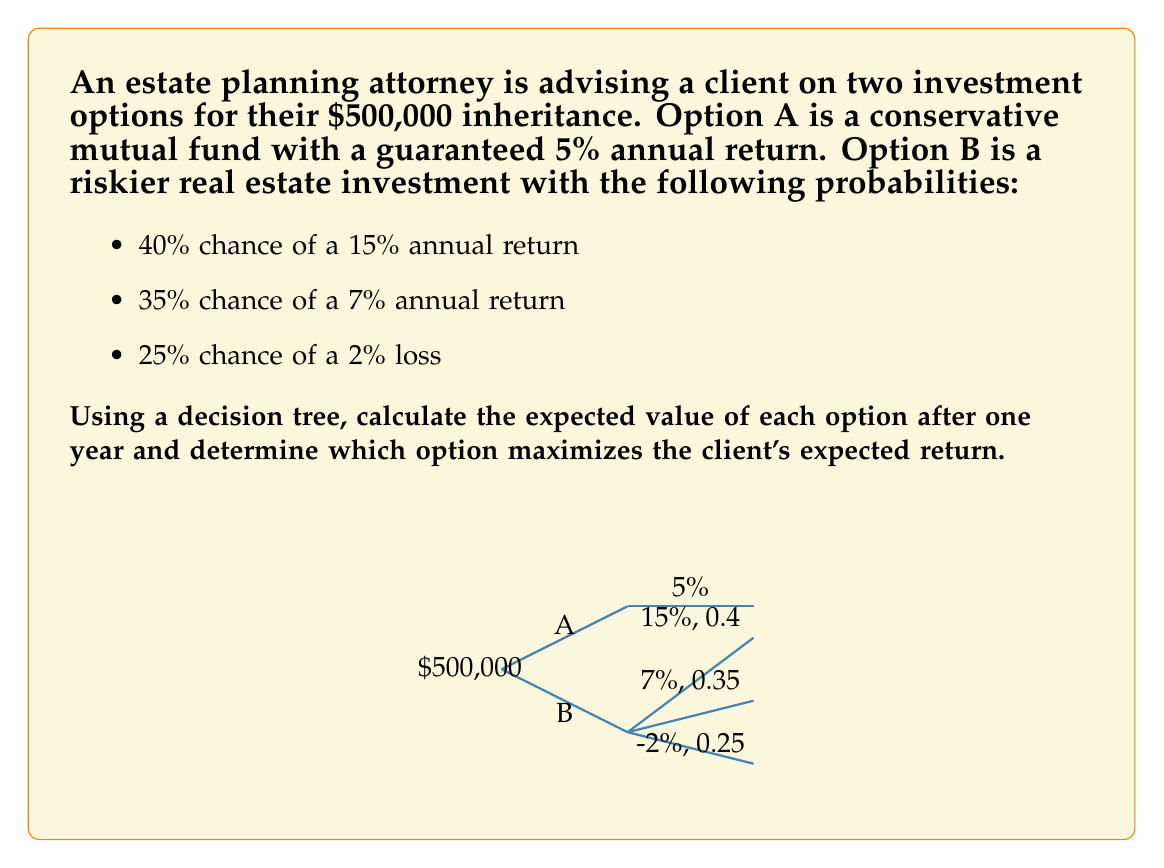Provide a solution to this math problem. Let's approach this step-by-step:

1) For Option A (Conservative Mutual Fund):
   The return is guaranteed at 5%.
   Expected Value = $500,000 * (1 + 0.05) = $525,000

2) For Option B (Risky Real Estate Investment):
   We need to calculate the expected value using the given probabilities.

   a) 15% return: $500,000 * (1 + 0.15) * 0.4 = $230,000
   b) 7% return:  $500,000 * (1 + 0.07) * 0.35 = $187,250
   c) 2% loss:    $500,000 * (1 - 0.02) * 0.25 = $122,500

   Expected Value = $230,000 + $187,250 + $122,500 = $539,750

3) Comparing the two options:
   Option A: $525,000
   Option B: $539,750

   The difference is: $539,750 - $525,000 = $14,750

4) Decision:
   Option B has a higher expected value by $14,750, so it maximizes the client's expected return.

5) Calculating the expected return rate for Option B:
   Expected return rate = ($539,750 - $500,000) / $500,000 * 100% = 7.95%

The decision tree analysis shows that despite the risk, Option B offers a higher expected return of 7.95% compared to the guaranteed 5% of Option A.
Answer: Option B, with an expected value of $539,750 and an expected return rate of 7.95%. 